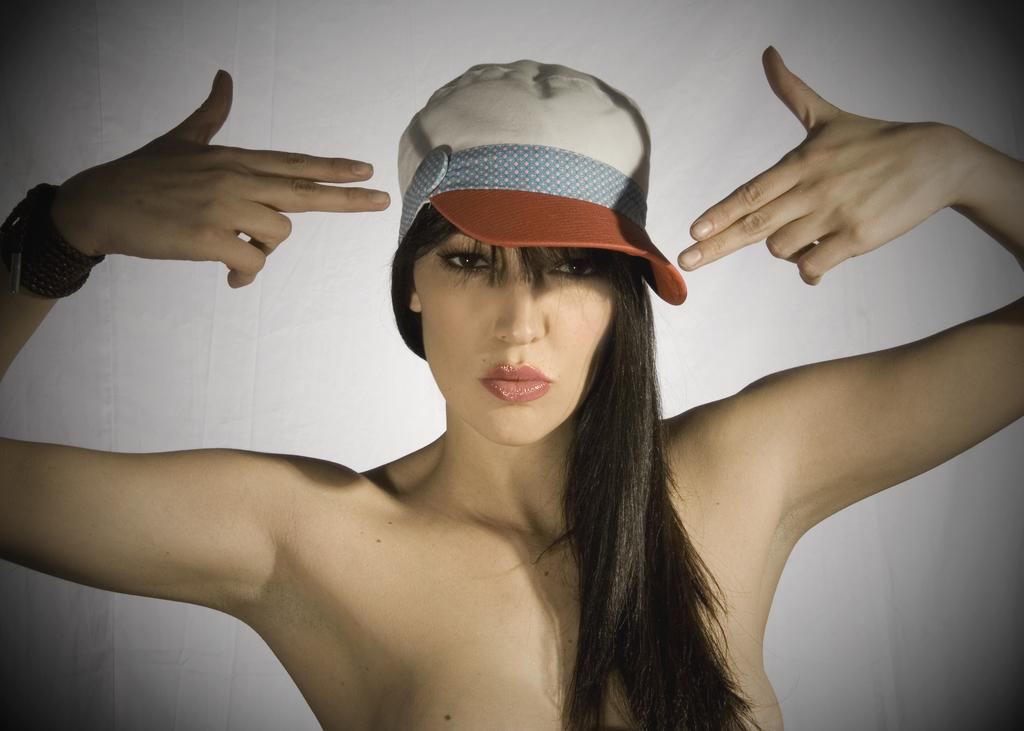Who is present in the image? There is a woman in the image. What is the woman wearing on her head? The woman is wearing a hat. What colors can be seen on the hat? The hat is white, red, and blue in color. What type of hen can be seen in the image? There is no hen present in the image; it features a woman wearing a hat. What does the apple smell like in the image? There is no apple present in the image, so it cannot be determined what it might smell like. 